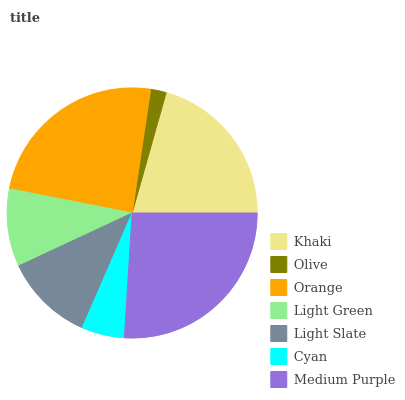Is Olive the minimum?
Answer yes or no. Yes. Is Medium Purple the maximum?
Answer yes or no. Yes. Is Orange the minimum?
Answer yes or no. No. Is Orange the maximum?
Answer yes or no. No. Is Orange greater than Olive?
Answer yes or no. Yes. Is Olive less than Orange?
Answer yes or no. Yes. Is Olive greater than Orange?
Answer yes or no. No. Is Orange less than Olive?
Answer yes or no. No. Is Light Slate the high median?
Answer yes or no. Yes. Is Light Slate the low median?
Answer yes or no. Yes. Is Orange the high median?
Answer yes or no. No. Is Light Green the low median?
Answer yes or no. No. 